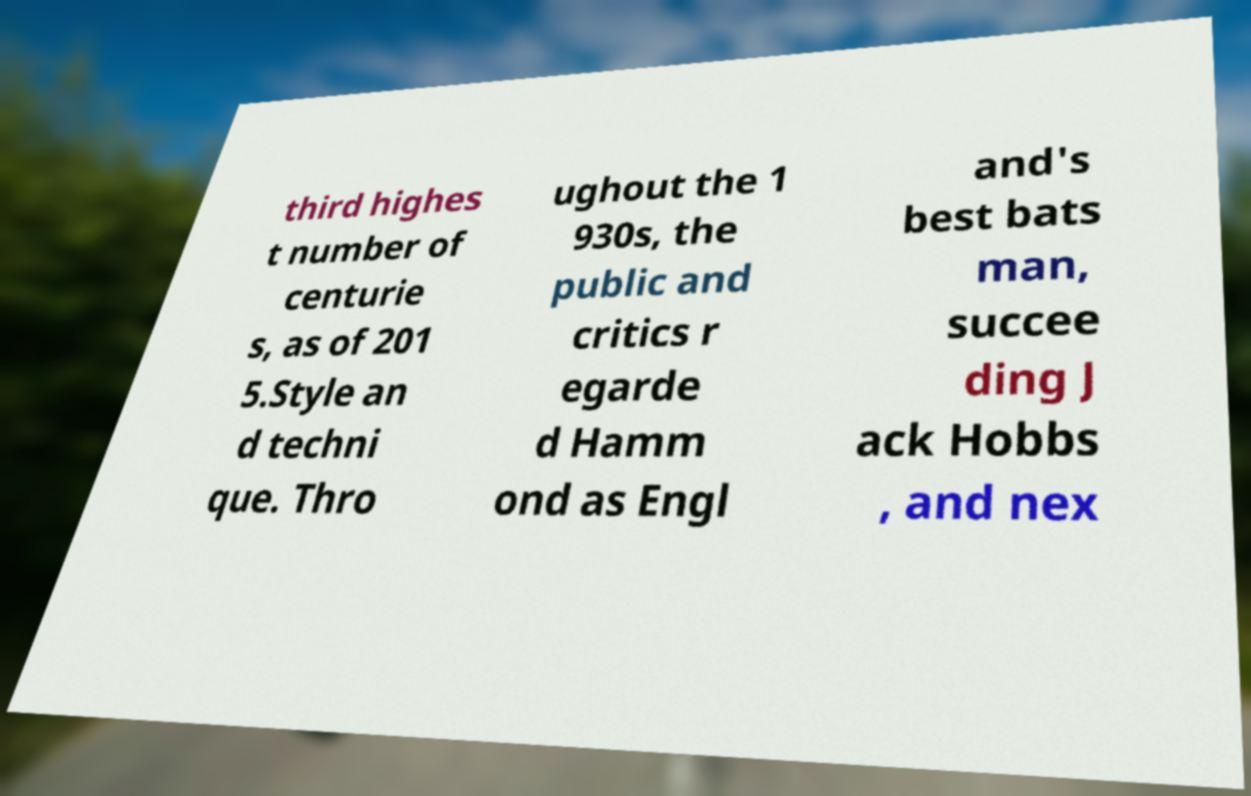Please read and relay the text visible in this image. What does it say? third highes t number of centurie s, as of 201 5.Style an d techni que. Thro ughout the 1 930s, the public and critics r egarde d Hamm ond as Engl and's best bats man, succee ding J ack Hobbs , and nex 